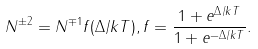Convert formula to latex. <formula><loc_0><loc_0><loc_500><loc_500>N ^ { \pm 2 } = N ^ { \mp 1 } f ( \Delta / k T ) , f = \frac { 1 + e ^ { \Delta / k T } } { 1 + e ^ { - \Delta / k T } } .</formula> 